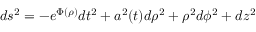<formula> <loc_0><loc_0><loc_500><loc_500>d s ^ { 2 } = - e ^ { \Phi ( \rho ) } d t ^ { 2 } + a ^ { 2 } ( t ) d \rho ^ { 2 } + \rho ^ { 2 } d \phi ^ { 2 } + d z ^ { 2 }</formula> 